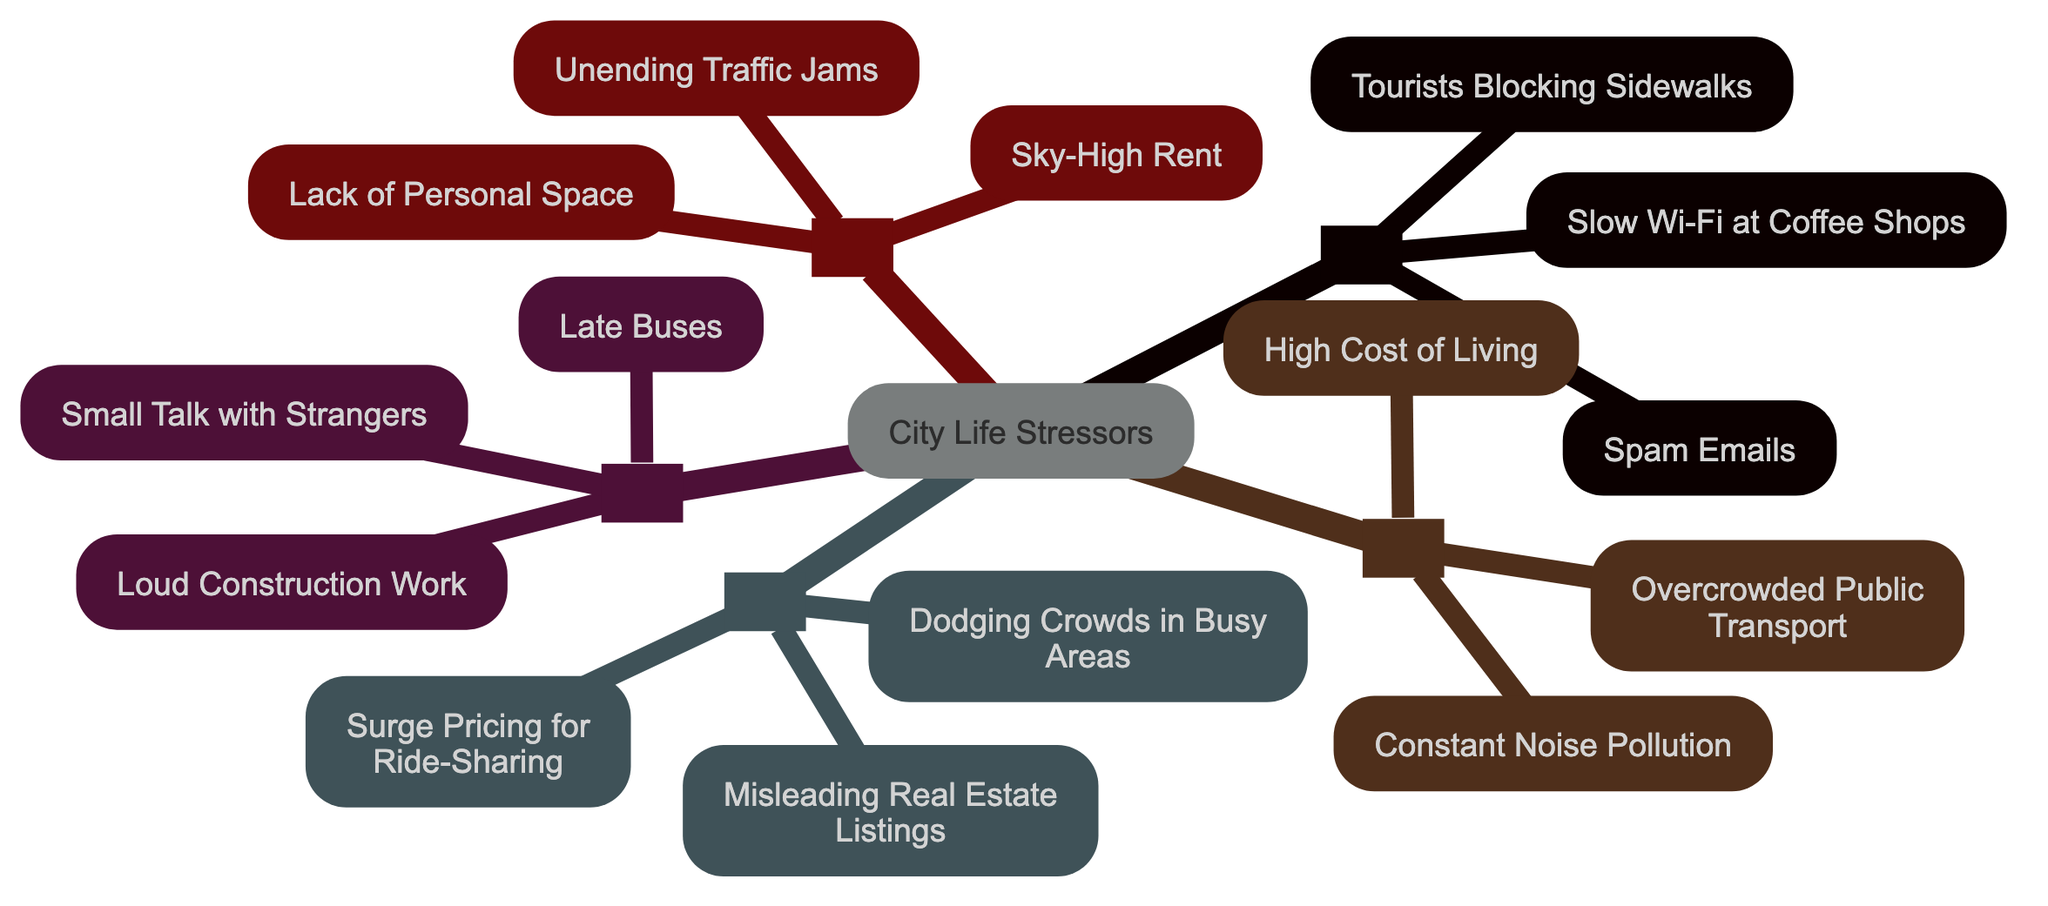What's the most stressful annoyance according to the diagram? The diagram categorizes annoyances from mildly irritating to soul-crushing, with "Unending Traffic Jams" being listed as part of the "Soul-Crushing" category, which is the most stressful group.
Answer: Unending Traffic Jams How many categories of stressors are represented in the diagram? The diagram displays five distinct categories that rank daily annoyances, from "Mildly Irritating" to "Soul-Crushing."
Answer: 5 What is the relationship between "High Cost of Living" and "Overcrowded Public Transport"? Both are located in the "Highly Stressful" category, indicating they share a similar level of annoyance and impact on city life.
Answer: Highly Stressful Which annoyance falls under the category of "Moderately Annoying"? The question looks for an example from the "Moderately Annoying" category, where "Late Buses" is explicitly listed as one of the examples.
Answer: Late Buses Which annoyance does not belong to the "Soul-Crushing" category? The question aims to identify an annoyance that is categorized lower than "Soul-Crushing," and "Spam Emails," which is in the "Mildly Irritating" category, is an appropriate answer.
Answer: Spam Emails What is the lowest-ranked stressor in the diagram? The lowest-ranked stressor is associated with the least severe category, "Mildly Irritating," which includes annoyances such as "Slow Wi-Fi at Coffee Shops."
Answer: Slow Wi-Fi at Coffee Shops Name an annoyance that falls under "Quite Frustrating." The question is asking for an example from the "Quite Frustrating" category; "Surge Pricing for Ride-Sharing" is one of the listed examples.
Answer: Surge Pricing for Ride-Sharing How many annoyances are listed under the "Highly Stressful" category? To find the answer, we need to count the examples in that category: "Overcrowded Public Transport," "Constant Noise Pollution," and "High Cost of Living" amount to three annoyances.
Answer: 3 